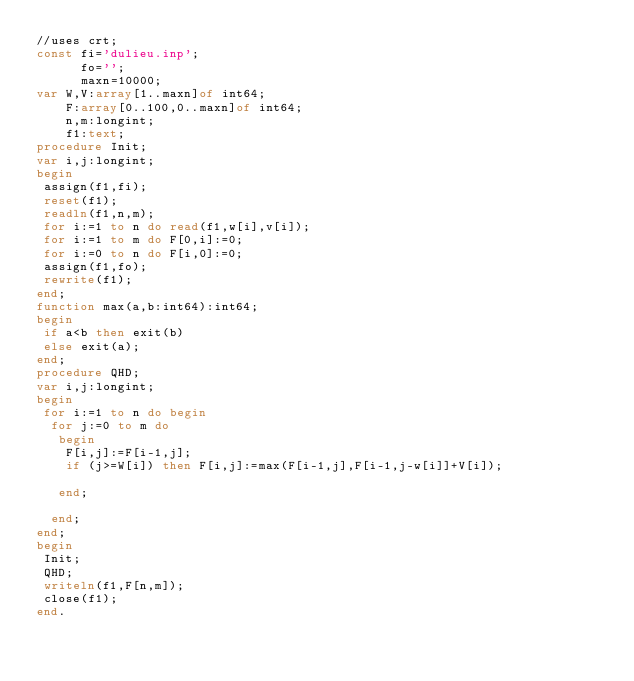Convert code to text. <code><loc_0><loc_0><loc_500><loc_500><_Pascal_>//uses crt;
const fi='dulieu.inp';
      fo='';
      maxn=10000;
var W,V:array[1..maxn]of int64;
    F:array[0..100,0..maxn]of int64;
    n,m:longint;
    f1:text;
procedure Init;
var i,j:longint;
begin
 assign(f1,fi);
 reset(f1);
 readln(f1,n,m);
 for i:=1 to n do read(f1,w[i],v[i]);
 for i:=1 to m do F[0,i]:=0;
 for i:=0 to n do F[i,0]:=0;
 assign(f1,fo);
 rewrite(f1);
end;
function max(a,b:int64):int64;
begin
 if a<b then exit(b)
 else exit(a);
end;
procedure QHD;
var i,j:longint;
begin
 for i:=1 to n do begin
  for j:=0 to m do
   begin
    F[i,j]:=F[i-1,j];
    if (j>=W[i]) then F[i,j]:=max(F[i-1,j],F[i-1,j-w[i]]+V[i]);
	
   end;

  end;
end;
begin
 Init;
 QHD;
 writeln(f1,F[n,m]);
 close(f1);
end.</code> 